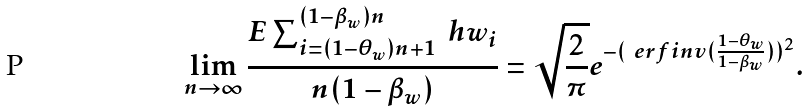Convert formula to latex. <formula><loc_0><loc_0><loc_500><loc_500>\lim _ { n \rightarrow \infty } \frac { E \sum _ { i = ( 1 - \theta _ { w } ) n + 1 } ^ { ( 1 - \beta _ { w } ) n } \ h w _ { i } } { n ( 1 - \beta _ { w } ) } = \sqrt { \frac { 2 } { \pi } } e ^ { - ( \ e r f i n v ( \frac { 1 - \theta _ { w } } { 1 - \beta _ { w } } ) ) ^ { 2 } } .</formula> 